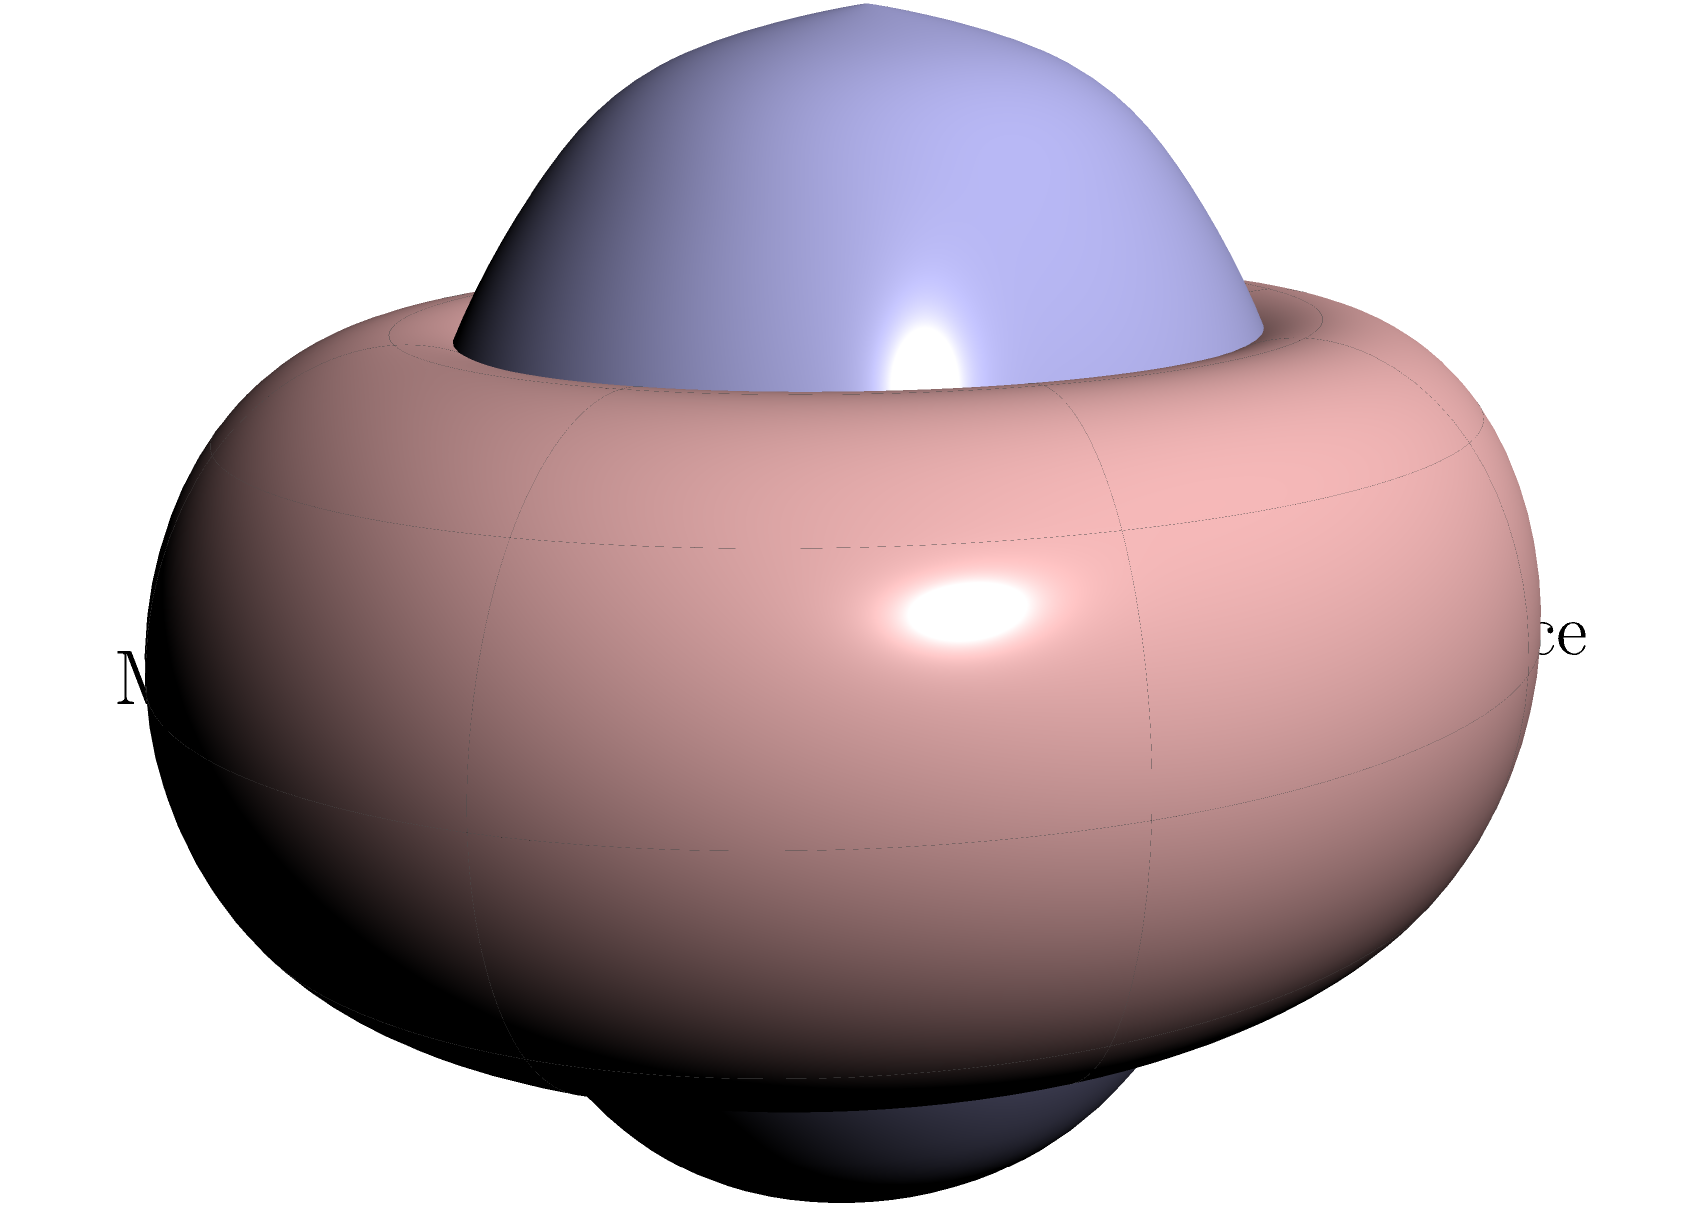In the context of machine learning algorithms dealing with high-dimensional data, how does the visualization of non-Euclidean spaces, as shown in the image, impact the representation and analysis of complex datasets? Specifically, consider the implications for dimensionality reduction techniques and the potential vulnerabilities in security applications. To understand the impact of non-Euclidean spaces on machine learning algorithms and their security implications, let's break down the problem step-by-step:

1. Visualization of non-Euclidean spaces:
   The image shows a comparison between a hyperbolic space (blue surface) and a Euclidean space (red surface), with a manifold representing machine learning data.

2. High-dimensional data representation:
   In machine learning, datasets often have many features, creating high-dimensional spaces that are difficult to visualize and analyze in traditional Euclidean geometry.

3. Non-Euclidean geometry in data science:
   Non-Euclidean geometries, like hyperbolic spaces, can better represent complex relationships in high-dimensional data, as they allow for exponential growth in space as dimensions increase.

4. Dimensionality reduction:
   Techniques like t-SNE or UMAP attempt to preserve local and global structure when projecting high-dimensional data to lower dimensions. In non-Euclidean spaces, these methods may more accurately represent complex data relationships.

5. Impact on machine learning algorithms:
   Traditional algorithms often assume Euclidean geometry. Using non-Euclidean representations can lead to more accurate models for complex datasets, potentially improving classification, clustering, and anomaly detection.

6. Security implications:
   a) Improved threat detection: Better representation of complex data relationships can enhance the identification of subtle patterns in security-related datasets.
   b) Adversarial attacks: Non-Euclidean representations may be more robust against certain types of adversarial examples, as they can capture more intricate data structures.
   c) Privacy concerns: Enhanced data representation might lead to unintended information leakage, requiring careful consideration of privacy-preserving techniques.

7. Vulnerabilities:
   a) Computational complexity: Non-Euclidean algorithms may be more computationally intensive, potentially creating performance bottlenecks or vulnerabilities to denial-of-service attacks.
   b) Interpretability challenges: The increased complexity of non-Euclidean representations may make it harder for security analysts to interpret model decisions.
   c) Transfer learning issues: Models trained on non-Euclidean representations may not transfer well to traditional Euclidean-based systems, creating potential vulnerabilities at integration points.

8. Mitigation strategies:
   a) Robust testing: Implement rigorous testing protocols that account for both Euclidean and non-Euclidean data representations.
   b) Hybrid approaches: Combine Euclidean and non-Euclidean methods to balance performance, interpretability, and security.
   c) Advanced monitoring: Develop specialized monitoring tools to detect anomalies in non-Euclidean data spaces.
Answer: Non-Euclidean representations in ML improve complex data analysis but introduce new security considerations in computational complexity, interpretability, and system integration. 